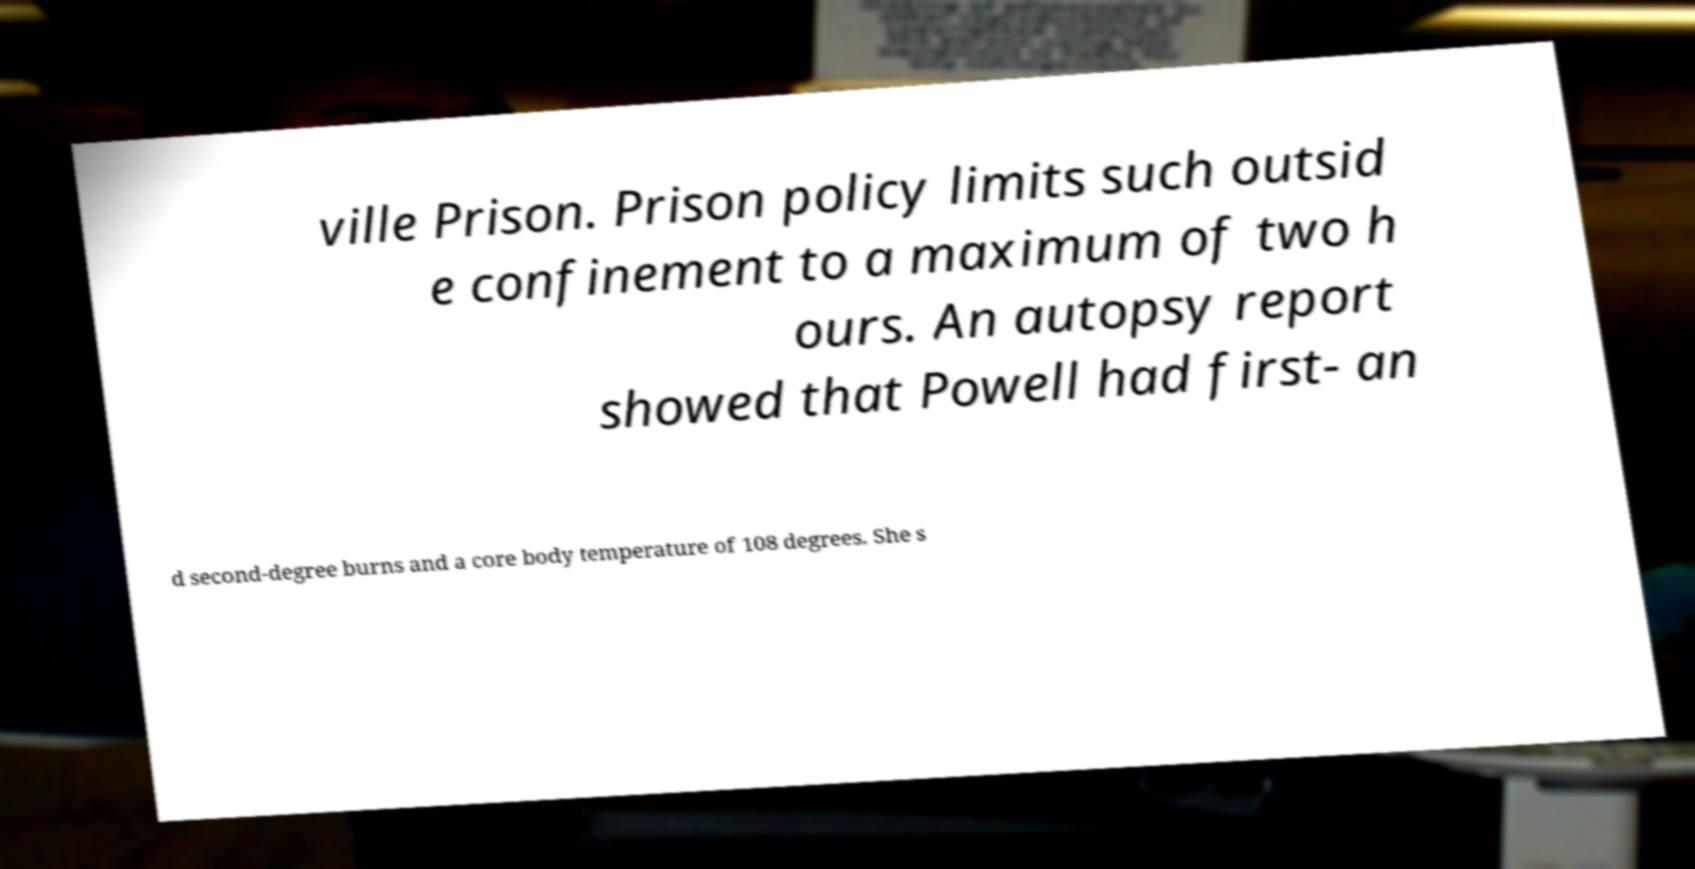What messages or text are displayed in this image? I need them in a readable, typed format. ville Prison. Prison policy limits such outsid e confinement to a maximum of two h ours. An autopsy report showed that Powell had first- an d second-degree burns and a core body temperature of 108 degrees. She s 